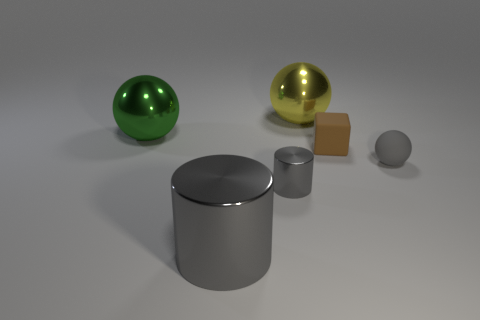Is the number of green metallic spheres that are in front of the large shiny cylinder less than the number of green balls?
Your answer should be compact. Yes. Is the shape of the tiny gray shiny thing that is in front of the yellow thing the same as  the large yellow thing?
Offer a very short reply. No. Is there anything else that has the same color as the tiny matte ball?
Keep it short and to the point. Yes. There is a brown object that is made of the same material as the tiny ball; what size is it?
Ensure brevity in your answer.  Small. The small gray thing that is to the right of the rubber thing behind the small matte object in front of the brown block is made of what material?
Make the answer very short. Rubber. Is the number of brown objects less than the number of cyan cylinders?
Make the answer very short. No. Is the tiny cube made of the same material as the green thing?
Provide a short and direct response. No. The tiny rubber thing that is the same color as the large cylinder is what shape?
Give a very brief answer. Sphere. There is a shiny cylinder behind the big gray cylinder; is it the same color as the big metallic cylinder?
Your answer should be very brief. Yes. How many gray cylinders are behind the large shiny object in front of the brown matte block?
Your answer should be compact. 1. 